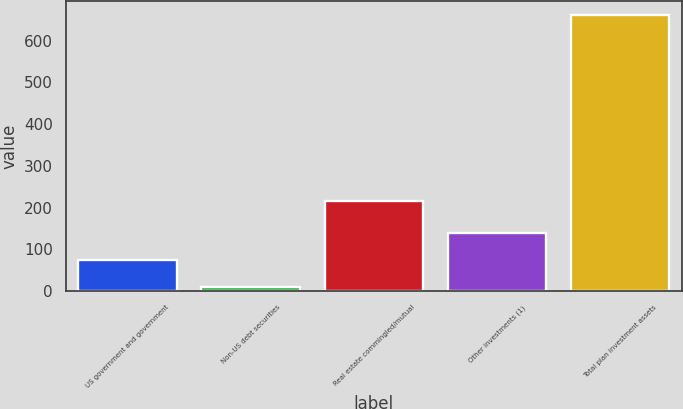Convert chart. <chart><loc_0><loc_0><loc_500><loc_500><bar_chart><fcel>US government and government<fcel>Non-US debt securities<fcel>Real estate commingled/mutual<fcel>Other investments (1)<fcel>Total plan investment assets<nl><fcel>74.2<fcel>9<fcel>215<fcel>139.4<fcel>661<nl></chart> 